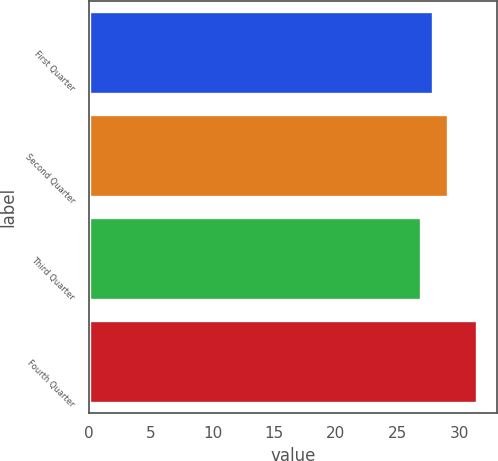Convert chart. <chart><loc_0><loc_0><loc_500><loc_500><bar_chart><fcel>First Quarter<fcel>Second Quarter<fcel>Third Quarter<fcel>Fourth Quarter<nl><fcel>27.88<fcel>29.07<fcel>26.88<fcel>31.47<nl></chart> 